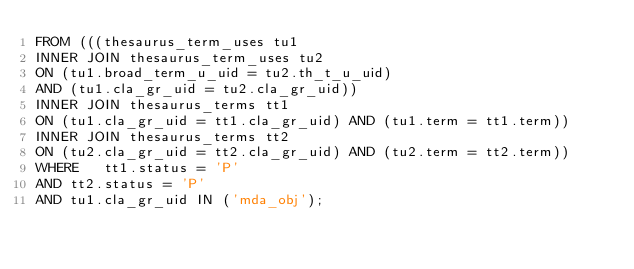<code> <loc_0><loc_0><loc_500><loc_500><_SQL_>FROM (((thesaurus_term_uses tu1 
INNER JOIN thesaurus_term_uses tu2 
ON (tu1.broad_term_u_uid = tu2.th_t_u_uid) 
AND (tu1.cla_gr_uid = tu2.cla_gr_uid))
INNER JOIN thesaurus_terms tt1 
ON (tu1.cla_gr_uid = tt1.cla_gr_uid) AND (tu1.term = tt1.term))
INNER JOIN thesaurus_terms tt2 
ON (tu2.cla_gr_uid = tt2.cla_gr_uid) AND (tu2.term = tt2.term))
WHERE 	tt1.status = 'P' 
AND	tt2.status = 'P' 
AND	tu1.cla_gr_uid IN ('mda_obj');</code> 